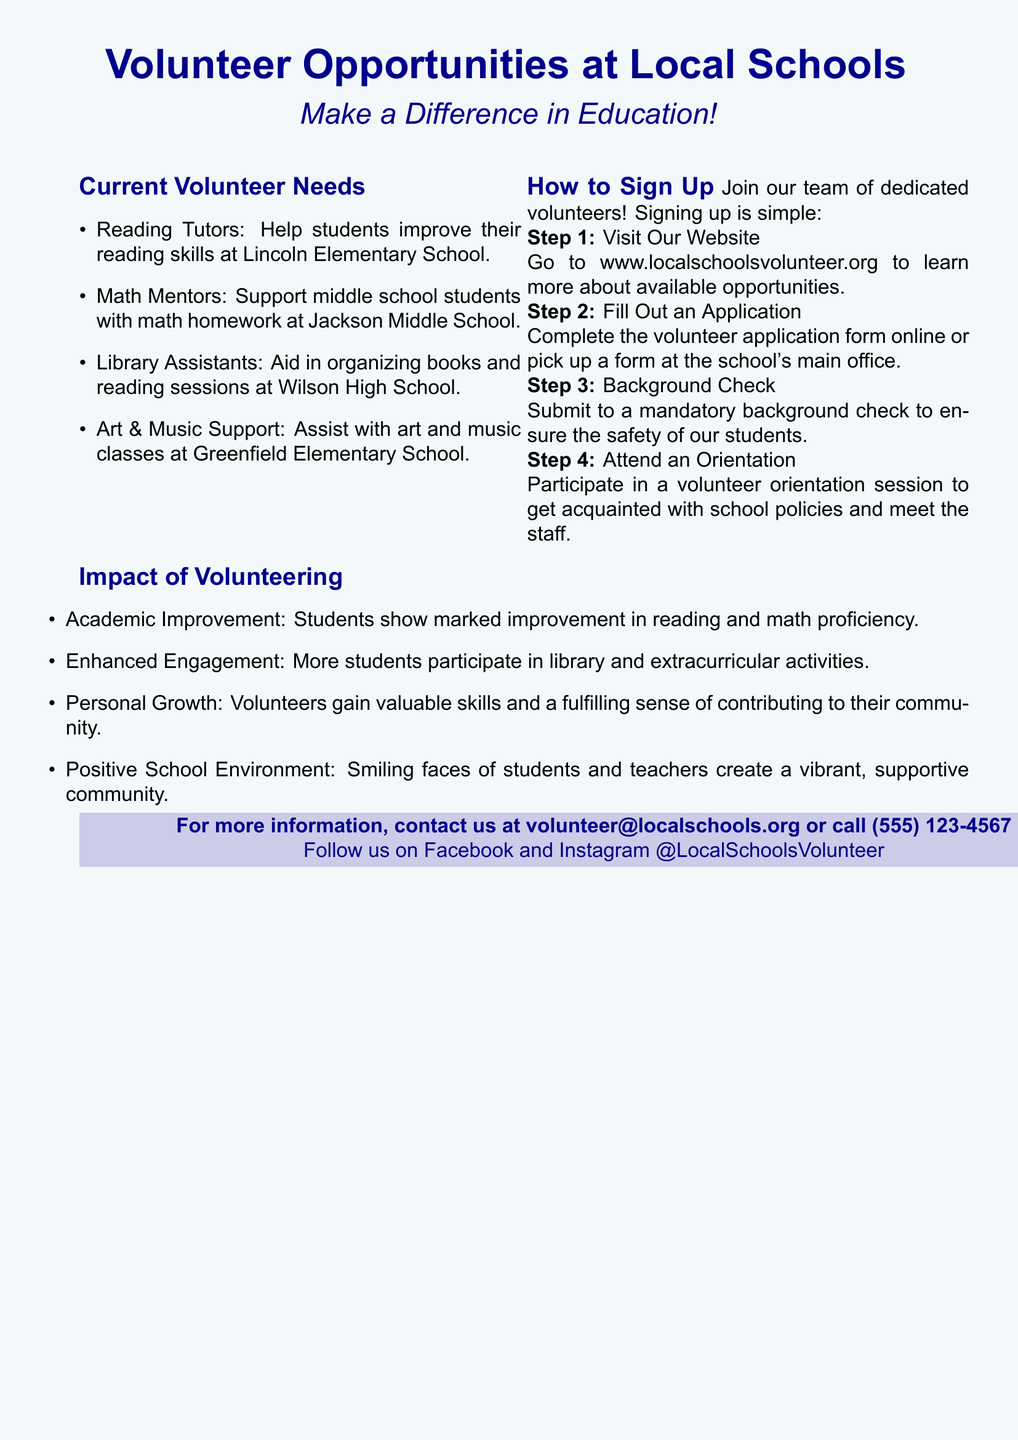What are the current volunteer needs? The document lists specific roles that are in demand for volunteers at local schools, including Reading Tutors and Math Mentors.
Answer: Reading Tutors, Math Mentors, Library Assistants, Art & Music Support How can I sign up to volunteer? The document outlines several steps to sign up, leading to the conclusion that it's a straightforward process.
Answer: Visit Our Website, Fill Out an Application, Background Check, Attend an Orientation What is the website to learn more about volunteer opportunities? The flyer provides a specific URL for obtaining more information about volunteering.
Answer: www.localschoolsvolunteer.org What is the phone number for more information? The document includes contact information, including a phone number for inquiries.
Answer: (555) 123-4567 What positive impact do volunteers have on students? The document discusses the benefits of volunteering, including academic improvement among students.
Answer: Academic Improvement How many steps are involved in the sign-up process? The document outlines four steps that are required for signing up as a volunteer.
Answer: Four What kind of orientation is required? The flyer mentions attending a specific type of session after the application submission.
Answer: Volunteer Orientation Which school needs Library Assistants? The flyer specifies which school requires volunteers for a particular role.
Answer: Wilson High School 